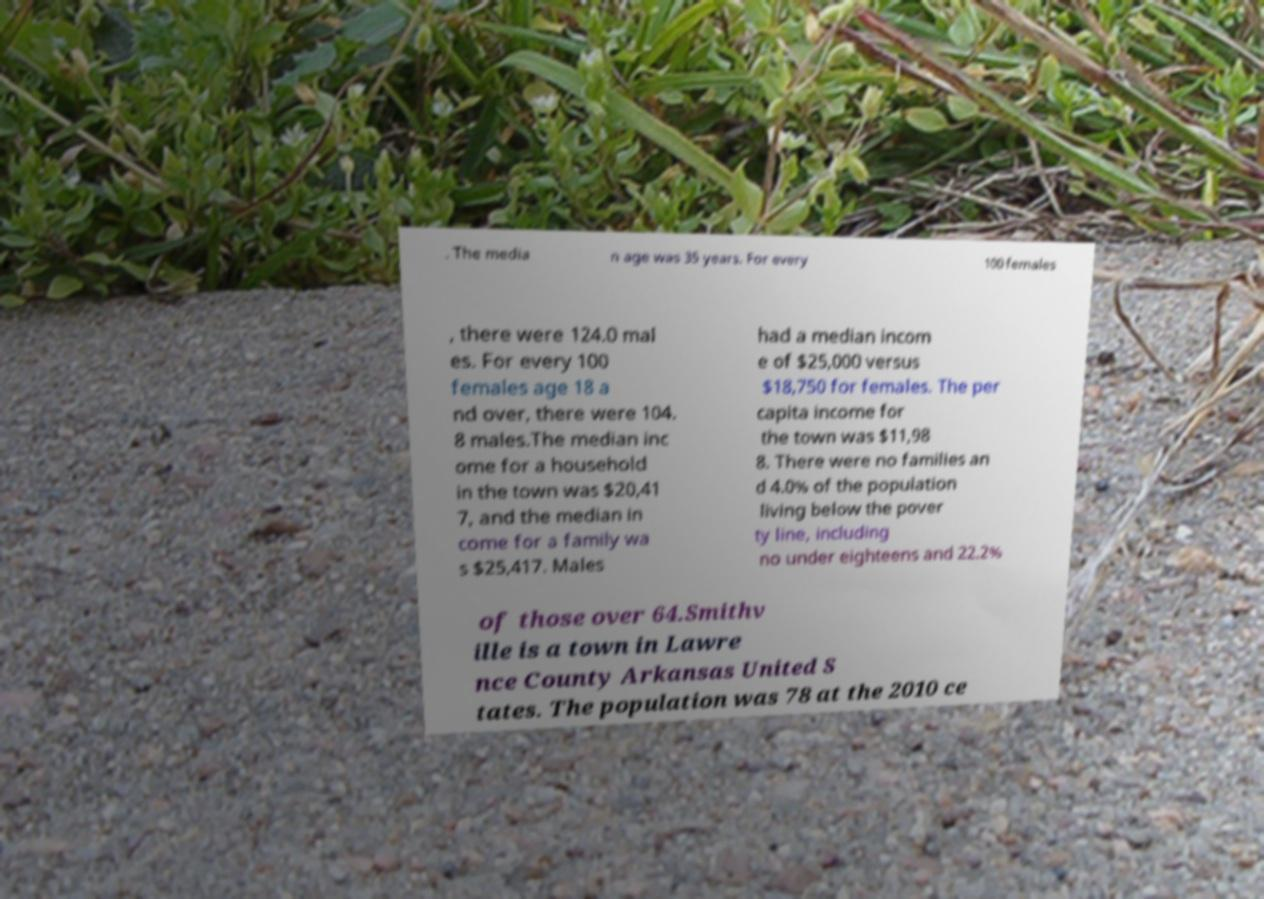I need the written content from this picture converted into text. Can you do that? . The media n age was 35 years. For every 100 females , there were 124.0 mal es. For every 100 females age 18 a nd over, there were 104. 8 males.The median inc ome for a household in the town was $20,41 7, and the median in come for a family wa s $25,417. Males had a median incom e of $25,000 versus $18,750 for females. The per capita income for the town was $11,98 8. There were no families an d 4.0% of the population living below the pover ty line, including no under eighteens and 22.2% of those over 64.Smithv ille is a town in Lawre nce County Arkansas United S tates. The population was 78 at the 2010 ce 